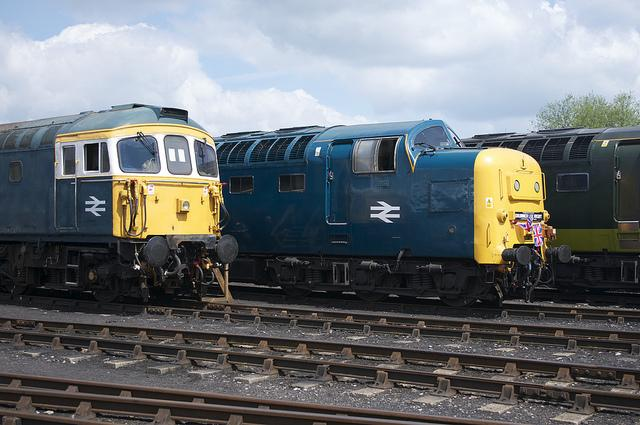The front of the vehicle is mostly the color of what? Please explain your reasoning. mustard. The most prevalent color on the front is yellow, the same color as mustard from the list. 